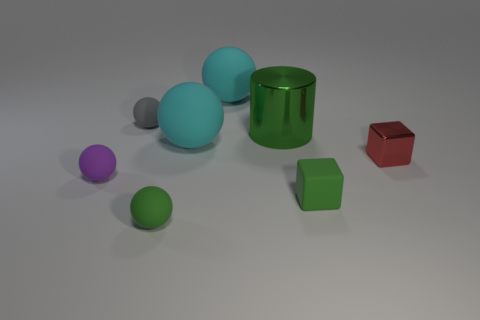Subtract all green matte spheres. How many spheres are left? 4 Subtract all brown balls. Subtract all red blocks. How many balls are left? 5 Add 1 purple objects. How many objects exist? 9 Subtract all cubes. How many objects are left? 6 Add 2 cyan matte objects. How many cyan matte objects exist? 4 Subtract 0 gray blocks. How many objects are left? 8 Subtract all small green rubber spheres. Subtract all metallic objects. How many objects are left? 5 Add 6 green rubber blocks. How many green rubber blocks are left? 7 